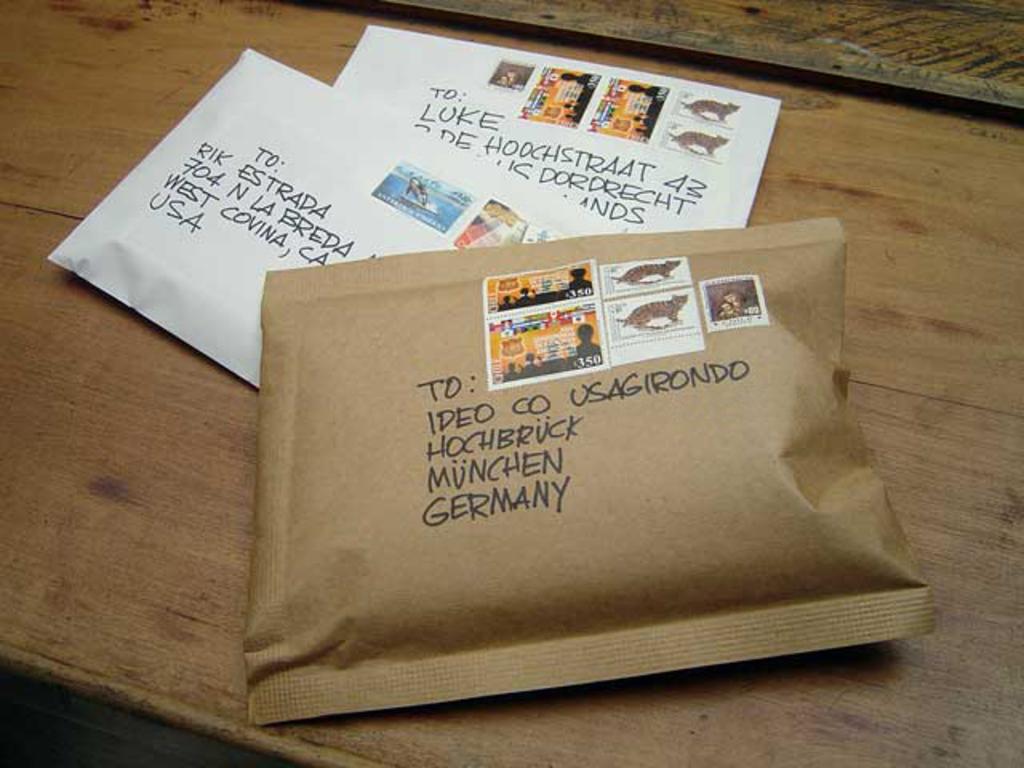What country is the brown package being sent to?
Provide a succinct answer. Germany. Who is the middle package for?
Offer a terse response. Rik estrada. 